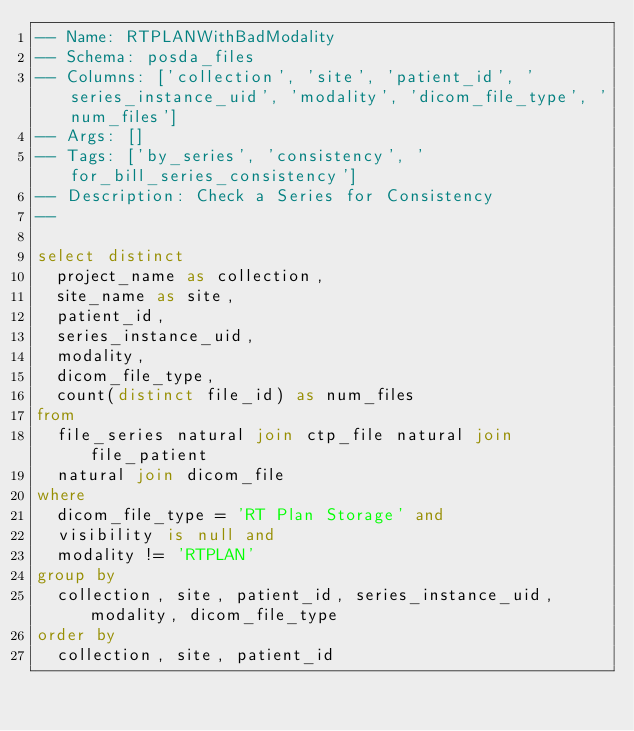<code> <loc_0><loc_0><loc_500><loc_500><_SQL_>-- Name: RTPLANWithBadModality
-- Schema: posda_files
-- Columns: ['collection', 'site', 'patient_id', 'series_instance_uid', 'modality', 'dicom_file_type', 'num_files']
-- Args: []
-- Tags: ['by_series', 'consistency', 'for_bill_series_consistency']
-- Description: Check a Series for Consistency
-- 

select distinct
  project_name as collection,
  site_name as site, 
  patient_id,
  series_instance_uid,
  modality,
  dicom_file_type,
  count(distinct file_id) as num_files
from
  file_series natural join ctp_file natural join file_patient
  natural join dicom_file
where 
  dicom_file_type = 'RT Plan Storage' and 
  visibility is null and
  modality != 'RTPLAN'
group by
  collection, site, patient_id, series_instance_uid, modality, dicom_file_type
order by
  collection, site, patient_id
</code> 